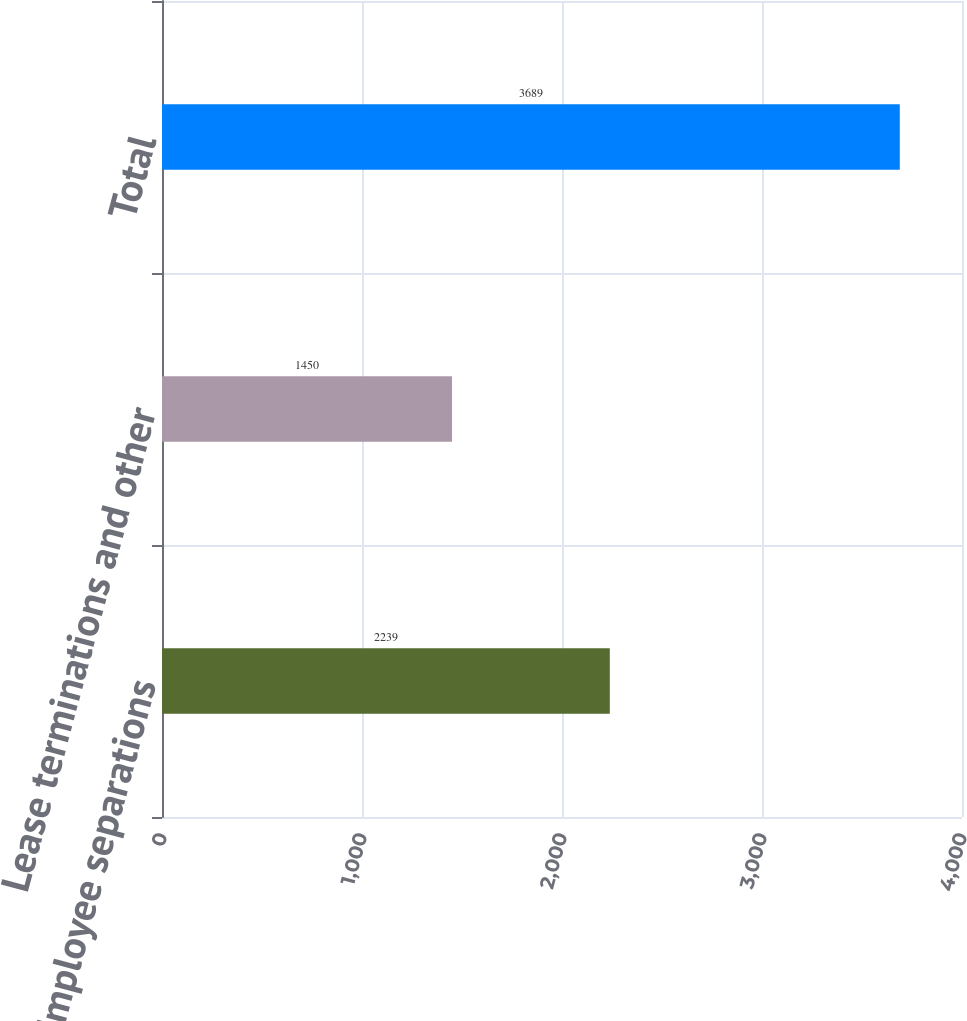Convert chart to OTSL. <chart><loc_0><loc_0><loc_500><loc_500><bar_chart><fcel>Employee separations<fcel>Lease terminations and other<fcel>Total<nl><fcel>2239<fcel>1450<fcel>3689<nl></chart> 